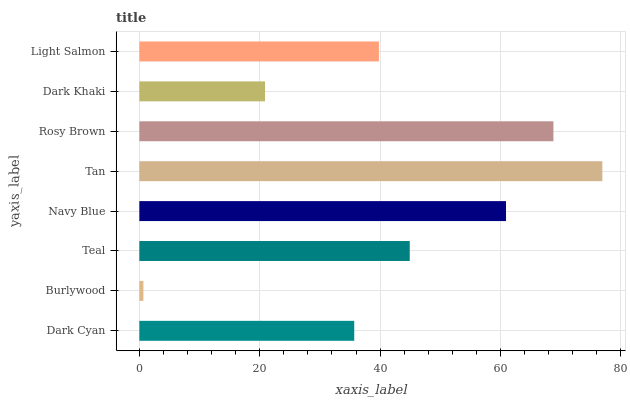Is Burlywood the minimum?
Answer yes or no. Yes. Is Tan the maximum?
Answer yes or no. Yes. Is Teal the minimum?
Answer yes or no. No. Is Teal the maximum?
Answer yes or no. No. Is Teal greater than Burlywood?
Answer yes or no. Yes. Is Burlywood less than Teal?
Answer yes or no. Yes. Is Burlywood greater than Teal?
Answer yes or no. No. Is Teal less than Burlywood?
Answer yes or no. No. Is Teal the high median?
Answer yes or no. Yes. Is Light Salmon the low median?
Answer yes or no. Yes. Is Navy Blue the high median?
Answer yes or no. No. Is Navy Blue the low median?
Answer yes or no. No. 